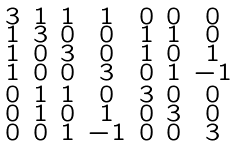Convert formula to latex. <formula><loc_0><loc_0><loc_500><loc_500>\begin{smallmatrix} 3 & 1 & 1 & 1 & 0 & 0 & 0 \\ 1 & 3 & 0 & 0 & 1 & 1 & 0 \\ 1 & 0 & 3 & 0 & 1 & 0 & 1 \\ 1 & 0 & 0 & 3 & 0 & 1 & - 1 \\ 0 & 1 & 1 & 0 & 3 & 0 & 0 \\ 0 & 1 & 0 & 1 & 0 & 3 & 0 \\ 0 & 0 & 1 & - 1 & 0 & 0 & 3 \end{smallmatrix}</formula> 